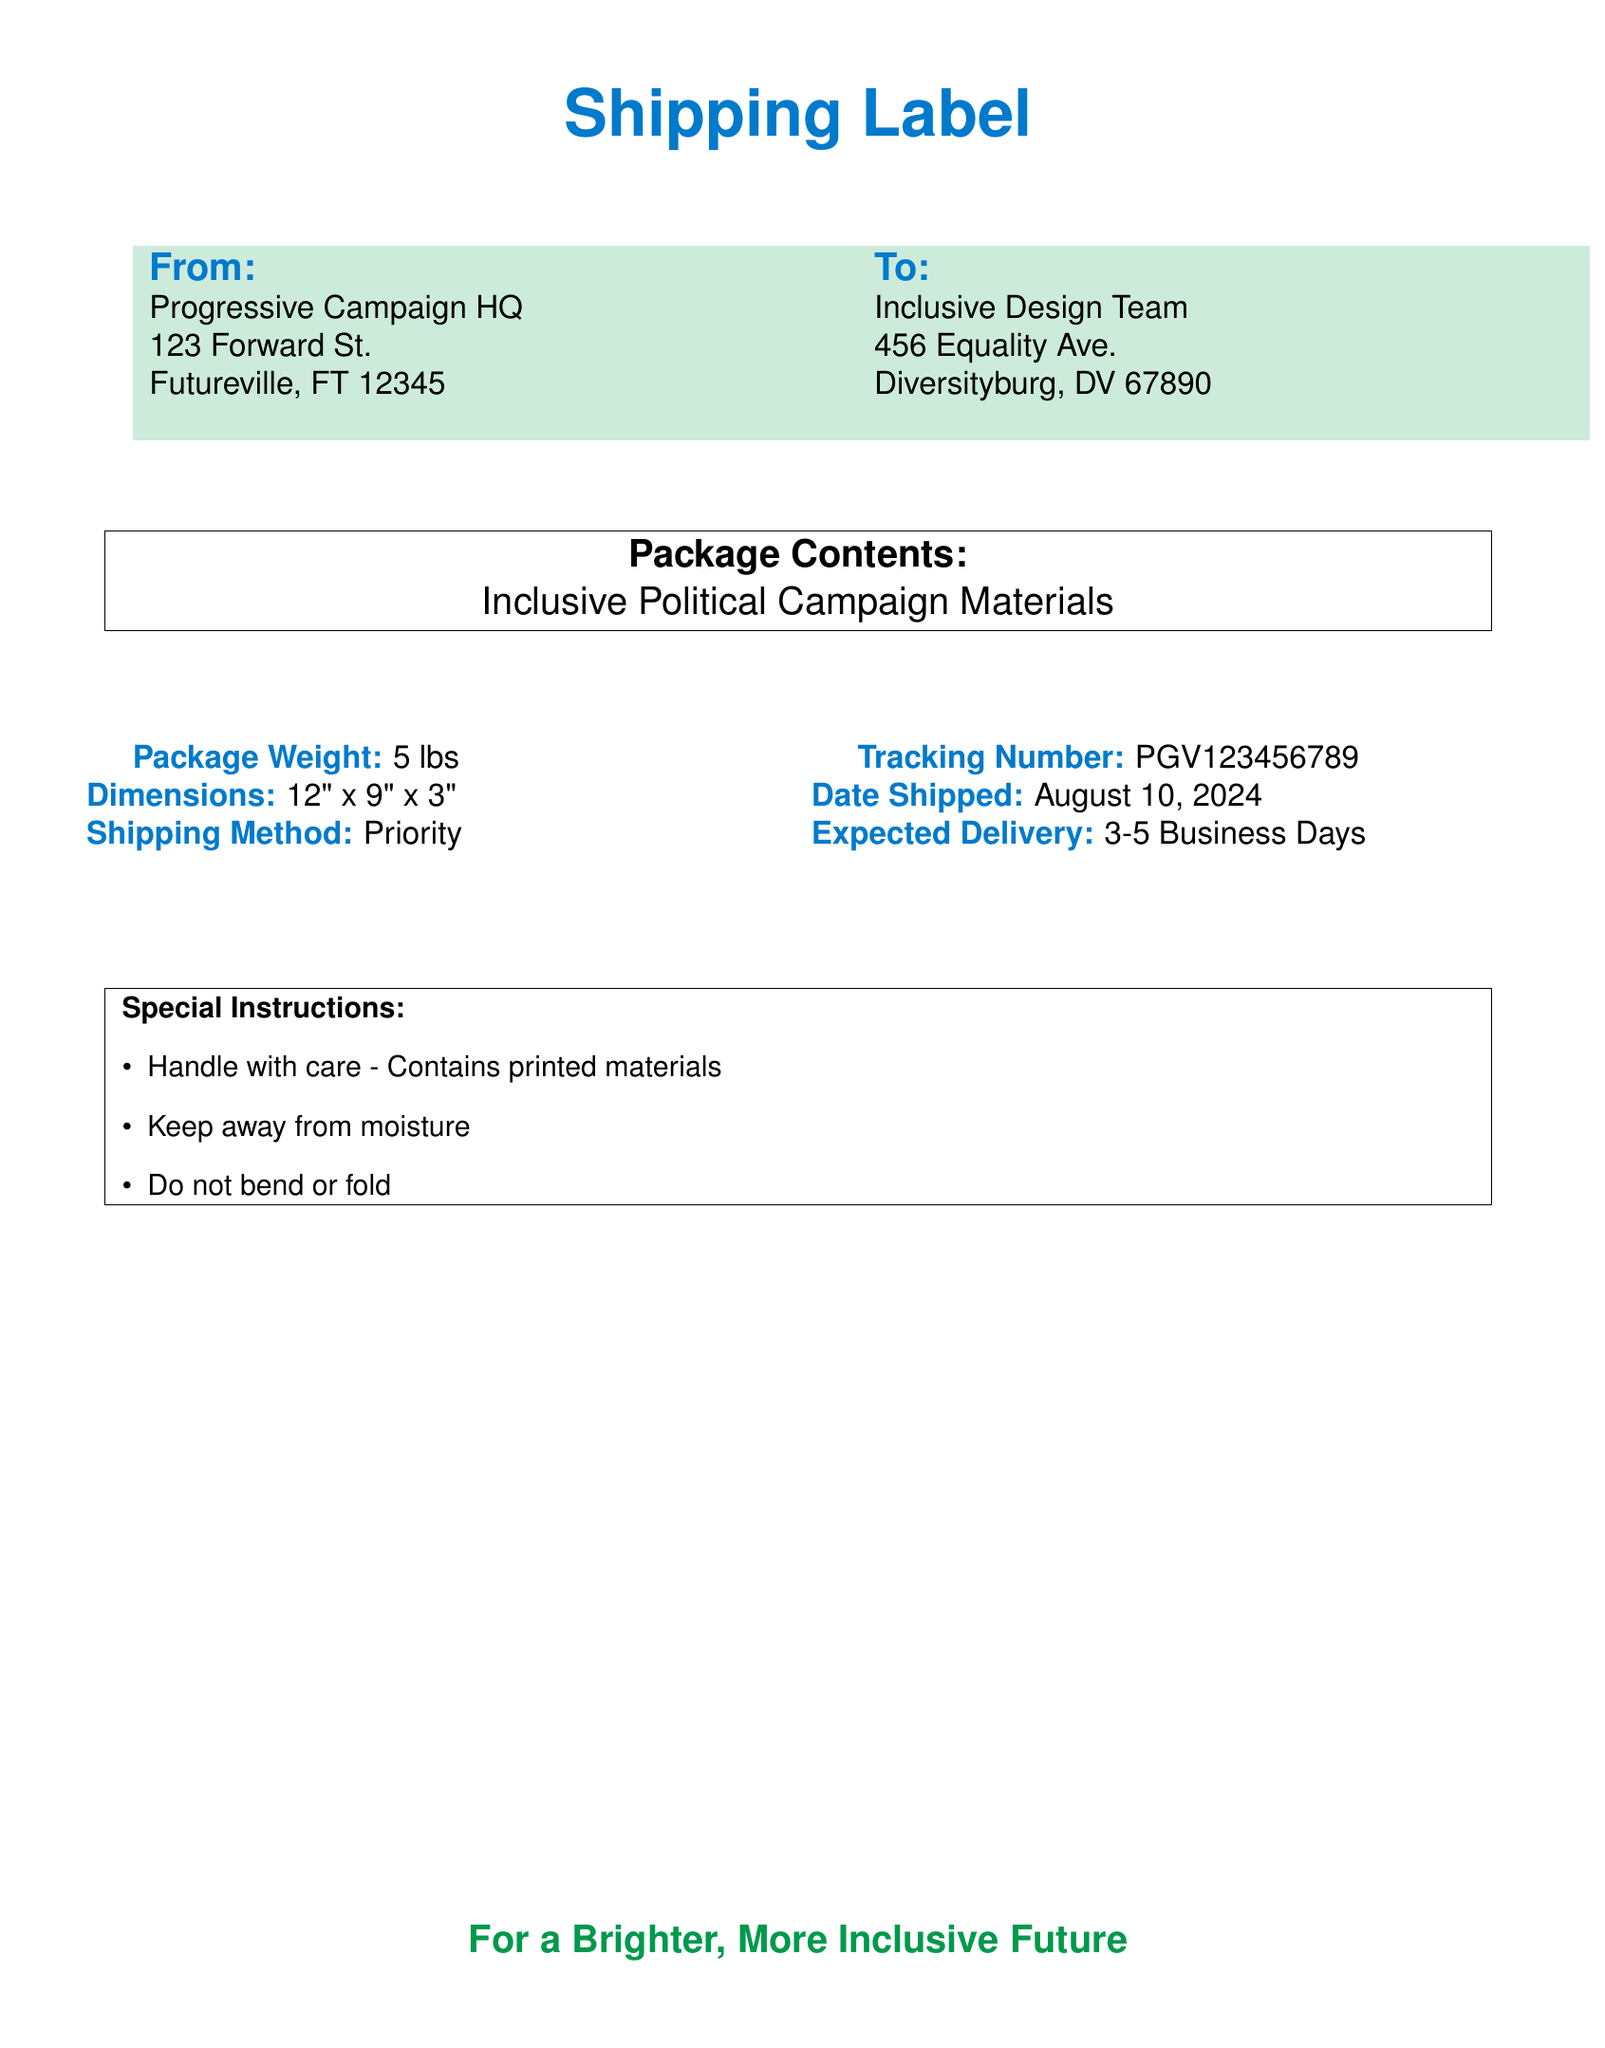What is the weight of the package? The weight of the package is mentioned in the shipping field of the document as "5 lbs."
Answer: 5 lbs What is the tracking number? The tracking number is specifically noted under the shipping field as "PGV123456789."
Answer: PGV123456789 What is the expected delivery timeframe? The expected delivery is specified as "3-5 Business Days" in the document.
Answer: 3-5 Business Days Who is the sender of the package? The sender's information is in the "From" section, detailing the sender as "Progressive Campaign HQ."
Answer: Progressive Campaign HQ What are the dimensions of the package? The dimensions are provided in the shipping field and are stated as "12\" x 9\" x 3\"."
Answer: 12" x 9" x 3" What is the shipping method used? The shipping method is clearly indicated in the document as "Priority."
Answer: Priority Give an example of a special instruction provided for the package. One of the special instructions listed states "Handle with care - Contains printed materials."
Answer: Handle with care - Contains printed materials What is the date the package was shipped? The date shipped is noted as "\today," which represents the current date when the document is generated.
Answer: \today What is the recipient's address? The recipient's address is outlined in the "To" section as "Inclusive Design Team, 456 Equality Ave., Diversityburg, DV 67890."
Answer: 456 Equality Ave., Diversityburg, DV 67890 